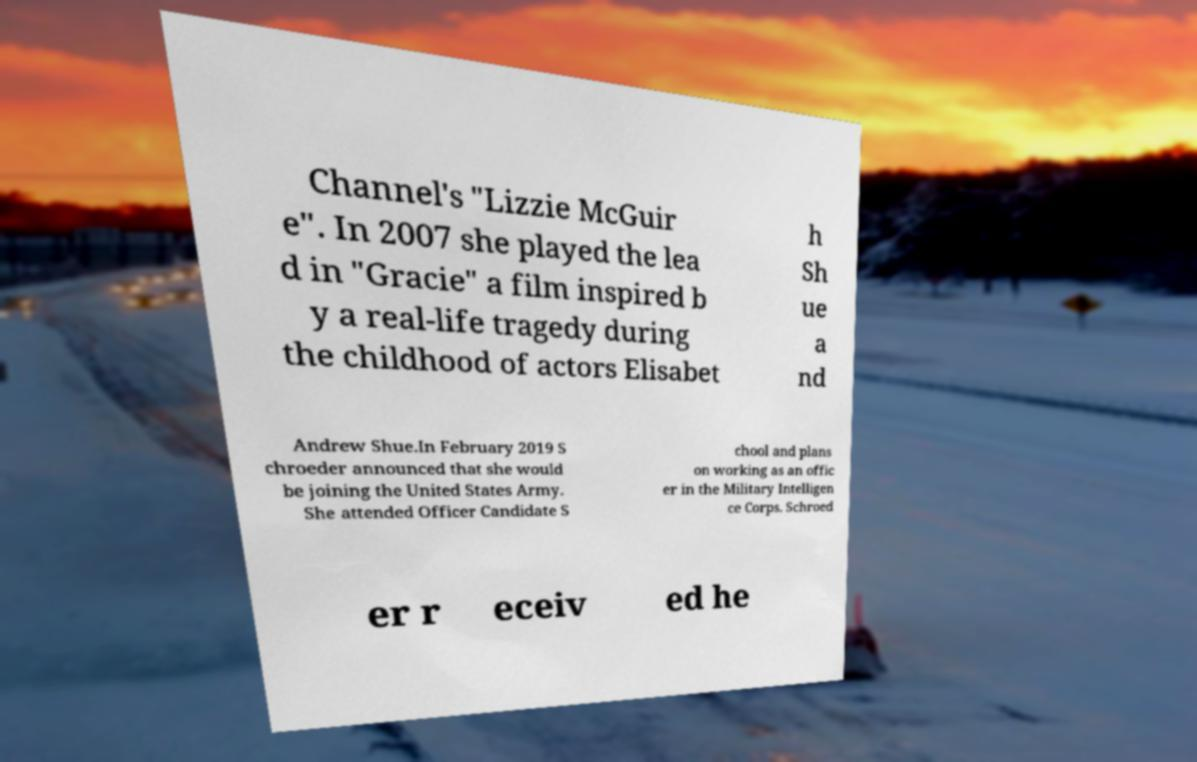Please identify and transcribe the text found in this image. Channel's "Lizzie McGuir e". In 2007 she played the lea d in "Gracie" a film inspired b y a real-life tragedy during the childhood of actors Elisabet h Sh ue a nd Andrew Shue.In February 2019 S chroeder announced that she would be joining the United States Army. She attended Officer Candidate S chool and plans on working as an offic er in the Military Intelligen ce Corps. Schroed er r eceiv ed he 